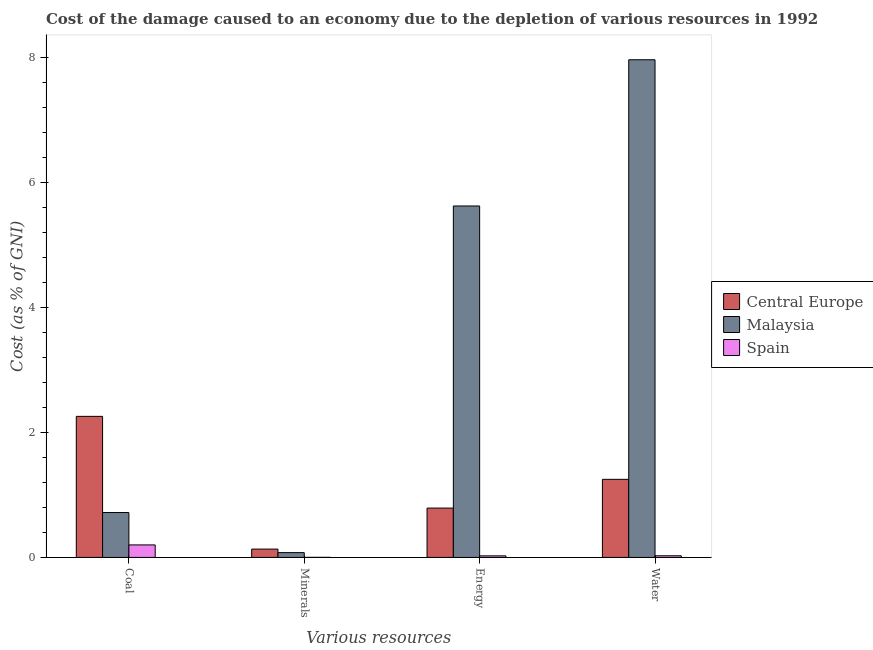How many different coloured bars are there?
Keep it short and to the point. 3. How many groups of bars are there?
Your answer should be very brief. 4. Are the number of bars per tick equal to the number of legend labels?
Your answer should be very brief. Yes. What is the label of the 3rd group of bars from the left?
Your response must be concise. Energy. What is the cost of damage due to depletion of minerals in Malaysia?
Provide a short and direct response. 0.08. Across all countries, what is the maximum cost of damage due to depletion of water?
Make the answer very short. 7.97. Across all countries, what is the minimum cost of damage due to depletion of water?
Make the answer very short. 0.03. In which country was the cost of damage due to depletion of coal maximum?
Your answer should be compact. Central Europe. What is the total cost of damage due to depletion of energy in the graph?
Keep it short and to the point. 6.44. What is the difference between the cost of damage due to depletion of energy in Malaysia and that in Central Europe?
Your response must be concise. 4.84. What is the difference between the cost of damage due to depletion of minerals in Malaysia and the cost of damage due to depletion of coal in Central Europe?
Keep it short and to the point. -2.18. What is the average cost of damage due to depletion of coal per country?
Make the answer very short. 1.06. What is the difference between the cost of damage due to depletion of coal and cost of damage due to depletion of energy in Malaysia?
Your response must be concise. -4.91. What is the ratio of the cost of damage due to depletion of water in Spain to that in Central Europe?
Give a very brief answer. 0.02. Is the cost of damage due to depletion of coal in Malaysia less than that in Central Europe?
Provide a short and direct response. Yes. What is the difference between the highest and the second highest cost of damage due to depletion of energy?
Your response must be concise. 4.84. What is the difference between the highest and the lowest cost of damage due to depletion of water?
Ensure brevity in your answer.  7.94. What does the 1st bar from the left in Energy represents?
Provide a short and direct response. Central Europe. What does the 2nd bar from the right in Coal represents?
Your answer should be very brief. Malaysia. Is it the case that in every country, the sum of the cost of damage due to depletion of coal and cost of damage due to depletion of minerals is greater than the cost of damage due to depletion of energy?
Provide a short and direct response. No. How many countries are there in the graph?
Your answer should be compact. 3. Are the values on the major ticks of Y-axis written in scientific E-notation?
Your answer should be very brief. No. Does the graph contain grids?
Make the answer very short. No. How many legend labels are there?
Offer a terse response. 3. How are the legend labels stacked?
Offer a very short reply. Vertical. What is the title of the graph?
Give a very brief answer. Cost of the damage caused to an economy due to the depletion of various resources in 1992 . What is the label or title of the X-axis?
Give a very brief answer. Various resources. What is the label or title of the Y-axis?
Keep it short and to the point. Cost (as % of GNI). What is the Cost (as % of GNI) of Central Europe in Coal?
Your answer should be very brief. 2.26. What is the Cost (as % of GNI) in Malaysia in Coal?
Offer a very short reply. 0.72. What is the Cost (as % of GNI) of Spain in Coal?
Give a very brief answer. 0.2. What is the Cost (as % of GNI) of Central Europe in Minerals?
Provide a succinct answer. 0.13. What is the Cost (as % of GNI) in Malaysia in Minerals?
Your answer should be very brief. 0.08. What is the Cost (as % of GNI) of Spain in Minerals?
Provide a short and direct response. 0. What is the Cost (as % of GNI) in Central Europe in Energy?
Provide a succinct answer. 0.79. What is the Cost (as % of GNI) in Malaysia in Energy?
Your answer should be compact. 5.63. What is the Cost (as % of GNI) in Spain in Energy?
Provide a short and direct response. 0.03. What is the Cost (as % of GNI) of Central Europe in Water?
Your answer should be very brief. 1.25. What is the Cost (as % of GNI) in Malaysia in Water?
Offer a very short reply. 7.97. What is the Cost (as % of GNI) in Spain in Water?
Your answer should be very brief. 0.03. Across all Various resources, what is the maximum Cost (as % of GNI) of Central Europe?
Your answer should be compact. 2.26. Across all Various resources, what is the maximum Cost (as % of GNI) of Malaysia?
Your answer should be very brief. 7.97. Across all Various resources, what is the maximum Cost (as % of GNI) in Spain?
Your answer should be compact. 0.2. Across all Various resources, what is the minimum Cost (as % of GNI) of Central Europe?
Give a very brief answer. 0.13. Across all Various resources, what is the minimum Cost (as % of GNI) in Malaysia?
Your answer should be very brief. 0.08. Across all Various resources, what is the minimum Cost (as % of GNI) in Spain?
Offer a terse response. 0. What is the total Cost (as % of GNI) in Central Europe in the graph?
Offer a very short reply. 4.43. What is the total Cost (as % of GNI) in Malaysia in the graph?
Keep it short and to the point. 14.39. What is the total Cost (as % of GNI) in Spain in the graph?
Keep it short and to the point. 0.25. What is the difference between the Cost (as % of GNI) of Central Europe in Coal and that in Minerals?
Your response must be concise. 2.12. What is the difference between the Cost (as % of GNI) of Malaysia in Coal and that in Minerals?
Provide a short and direct response. 0.64. What is the difference between the Cost (as % of GNI) of Spain in Coal and that in Minerals?
Your answer should be compact. 0.2. What is the difference between the Cost (as % of GNI) of Central Europe in Coal and that in Energy?
Provide a succinct answer. 1.47. What is the difference between the Cost (as % of GNI) of Malaysia in Coal and that in Energy?
Ensure brevity in your answer.  -4.91. What is the difference between the Cost (as % of GNI) in Spain in Coal and that in Energy?
Provide a short and direct response. 0.18. What is the difference between the Cost (as % of GNI) of Malaysia in Coal and that in Water?
Keep it short and to the point. -7.25. What is the difference between the Cost (as % of GNI) of Spain in Coal and that in Water?
Your response must be concise. 0.17. What is the difference between the Cost (as % of GNI) of Central Europe in Minerals and that in Energy?
Keep it short and to the point. -0.66. What is the difference between the Cost (as % of GNI) in Malaysia in Minerals and that in Energy?
Offer a very short reply. -5.55. What is the difference between the Cost (as % of GNI) of Spain in Minerals and that in Energy?
Your answer should be compact. -0.02. What is the difference between the Cost (as % of GNI) in Central Europe in Minerals and that in Water?
Provide a succinct answer. -1.12. What is the difference between the Cost (as % of GNI) in Malaysia in Minerals and that in Water?
Your answer should be compact. -7.89. What is the difference between the Cost (as % of GNI) in Spain in Minerals and that in Water?
Provide a short and direct response. -0.03. What is the difference between the Cost (as % of GNI) of Central Europe in Energy and that in Water?
Provide a succinct answer. -0.46. What is the difference between the Cost (as % of GNI) in Malaysia in Energy and that in Water?
Give a very brief answer. -2.34. What is the difference between the Cost (as % of GNI) in Spain in Energy and that in Water?
Your answer should be compact. -0. What is the difference between the Cost (as % of GNI) of Central Europe in Coal and the Cost (as % of GNI) of Malaysia in Minerals?
Ensure brevity in your answer.  2.18. What is the difference between the Cost (as % of GNI) of Central Europe in Coal and the Cost (as % of GNI) of Spain in Minerals?
Your response must be concise. 2.26. What is the difference between the Cost (as % of GNI) of Malaysia in Coal and the Cost (as % of GNI) of Spain in Minerals?
Ensure brevity in your answer.  0.72. What is the difference between the Cost (as % of GNI) of Central Europe in Coal and the Cost (as % of GNI) of Malaysia in Energy?
Your response must be concise. -3.37. What is the difference between the Cost (as % of GNI) in Central Europe in Coal and the Cost (as % of GNI) in Spain in Energy?
Make the answer very short. 2.23. What is the difference between the Cost (as % of GNI) of Malaysia in Coal and the Cost (as % of GNI) of Spain in Energy?
Offer a terse response. 0.69. What is the difference between the Cost (as % of GNI) of Central Europe in Coal and the Cost (as % of GNI) of Malaysia in Water?
Your answer should be very brief. -5.71. What is the difference between the Cost (as % of GNI) of Central Europe in Coal and the Cost (as % of GNI) of Spain in Water?
Keep it short and to the point. 2.23. What is the difference between the Cost (as % of GNI) of Malaysia in Coal and the Cost (as % of GNI) of Spain in Water?
Your response must be concise. 0.69. What is the difference between the Cost (as % of GNI) in Central Europe in Minerals and the Cost (as % of GNI) in Malaysia in Energy?
Your response must be concise. -5.49. What is the difference between the Cost (as % of GNI) of Central Europe in Minerals and the Cost (as % of GNI) of Spain in Energy?
Give a very brief answer. 0.11. What is the difference between the Cost (as % of GNI) of Malaysia in Minerals and the Cost (as % of GNI) of Spain in Energy?
Your answer should be very brief. 0.05. What is the difference between the Cost (as % of GNI) in Central Europe in Minerals and the Cost (as % of GNI) in Malaysia in Water?
Your answer should be very brief. -7.83. What is the difference between the Cost (as % of GNI) in Central Europe in Minerals and the Cost (as % of GNI) in Spain in Water?
Offer a terse response. 0.11. What is the difference between the Cost (as % of GNI) in Malaysia in Minerals and the Cost (as % of GNI) in Spain in Water?
Provide a succinct answer. 0.05. What is the difference between the Cost (as % of GNI) in Central Europe in Energy and the Cost (as % of GNI) in Malaysia in Water?
Ensure brevity in your answer.  -7.18. What is the difference between the Cost (as % of GNI) in Central Europe in Energy and the Cost (as % of GNI) in Spain in Water?
Keep it short and to the point. 0.76. What is the difference between the Cost (as % of GNI) in Malaysia in Energy and the Cost (as % of GNI) in Spain in Water?
Provide a short and direct response. 5.6. What is the average Cost (as % of GNI) in Central Europe per Various resources?
Your response must be concise. 1.11. What is the average Cost (as % of GNI) of Malaysia per Various resources?
Offer a very short reply. 3.6. What is the average Cost (as % of GNI) in Spain per Various resources?
Your response must be concise. 0.06. What is the difference between the Cost (as % of GNI) of Central Europe and Cost (as % of GNI) of Malaysia in Coal?
Offer a terse response. 1.54. What is the difference between the Cost (as % of GNI) of Central Europe and Cost (as % of GNI) of Spain in Coal?
Your response must be concise. 2.06. What is the difference between the Cost (as % of GNI) of Malaysia and Cost (as % of GNI) of Spain in Coal?
Offer a very short reply. 0.52. What is the difference between the Cost (as % of GNI) of Central Europe and Cost (as % of GNI) of Malaysia in Minerals?
Provide a short and direct response. 0.06. What is the difference between the Cost (as % of GNI) of Central Europe and Cost (as % of GNI) of Spain in Minerals?
Provide a succinct answer. 0.13. What is the difference between the Cost (as % of GNI) in Malaysia and Cost (as % of GNI) in Spain in Minerals?
Offer a very short reply. 0.08. What is the difference between the Cost (as % of GNI) in Central Europe and Cost (as % of GNI) in Malaysia in Energy?
Make the answer very short. -4.84. What is the difference between the Cost (as % of GNI) in Central Europe and Cost (as % of GNI) in Spain in Energy?
Offer a terse response. 0.76. What is the difference between the Cost (as % of GNI) in Malaysia and Cost (as % of GNI) in Spain in Energy?
Provide a short and direct response. 5.6. What is the difference between the Cost (as % of GNI) of Central Europe and Cost (as % of GNI) of Malaysia in Water?
Your response must be concise. -6.72. What is the difference between the Cost (as % of GNI) of Central Europe and Cost (as % of GNI) of Spain in Water?
Provide a short and direct response. 1.22. What is the difference between the Cost (as % of GNI) in Malaysia and Cost (as % of GNI) in Spain in Water?
Provide a short and direct response. 7.94. What is the ratio of the Cost (as % of GNI) in Central Europe in Coal to that in Minerals?
Your answer should be compact. 16.93. What is the ratio of the Cost (as % of GNI) of Malaysia in Coal to that in Minerals?
Provide a short and direct response. 9.35. What is the ratio of the Cost (as % of GNI) in Spain in Coal to that in Minerals?
Offer a very short reply. 176.08. What is the ratio of the Cost (as % of GNI) in Central Europe in Coal to that in Energy?
Offer a very short reply. 2.86. What is the ratio of the Cost (as % of GNI) of Malaysia in Coal to that in Energy?
Your answer should be compact. 0.13. What is the ratio of the Cost (as % of GNI) in Spain in Coal to that in Energy?
Offer a terse response. 7.94. What is the ratio of the Cost (as % of GNI) of Central Europe in Coal to that in Water?
Provide a short and direct response. 1.81. What is the ratio of the Cost (as % of GNI) in Malaysia in Coal to that in Water?
Provide a short and direct response. 0.09. What is the ratio of the Cost (as % of GNI) of Spain in Coal to that in Water?
Your answer should be compact. 7.59. What is the ratio of the Cost (as % of GNI) of Central Europe in Minerals to that in Energy?
Offer a very short reply. 0.17. What is the ratio of the Cost (as % of GNI) of Malaysia in Minerals to that in Energy?
Provide a short and direct response. 0.01. What is the ratio of the Cost (as % of GNI) in Spain in Minerals to that in Energy?
Ensure brevity in your answer.  0.05. What is the ratio of the Cost (as % of GNI) of Central Europe in Minerals to that in Water?
Offer a terse response. 0.11. What is the ratio of the Cost (as % of GNI) in Malaysia in Minerals to that in Water?
Your answer should be compact. 0.01. What is the ratio of the Cost (as % of GNI) in Spain in Minerals to that in Water?
Your response must be concise. 0.04. What is the ratio of the Cost (as % of GNI) of Central Europe in Energy to that in Water?
Ensure brevity in your answer.  0.63. What is the ratio of the Cost (as % of GNI) in Malaysia in Energy to that in Water?
Offer a very short reply. 0.71. What is the ratio of the Cost (as % of GNI) in Spain in Energy to that in Water?
Provide a succinct answer. 0.96. What is the difference between the highest and the second highest Cost (as % of GNI) of Central Europe?
Keep it short and to the point. 1.01. What is the difference between the highest and the second highest Cost (as % of GNI) of Malaysia?
Offer a terse response. 2.34. What is the difference between the highest and the second highest Cost (as % of GNI) of Spain?
Ensure brevity in your answer.  0.17. What is the difference between the highest and the lowest Cost (as % of GNI) of Central Europe?
Offer a terse response. 2.12. What is the difference between the highest and the lowest Cost (as % of GNI) in Malaysia?
Your answer should be compact. 7.89. What is the difference between the highest and the lowest Cost (as % of GNI) in Spain?
Your answer should be compact. 0.2. 